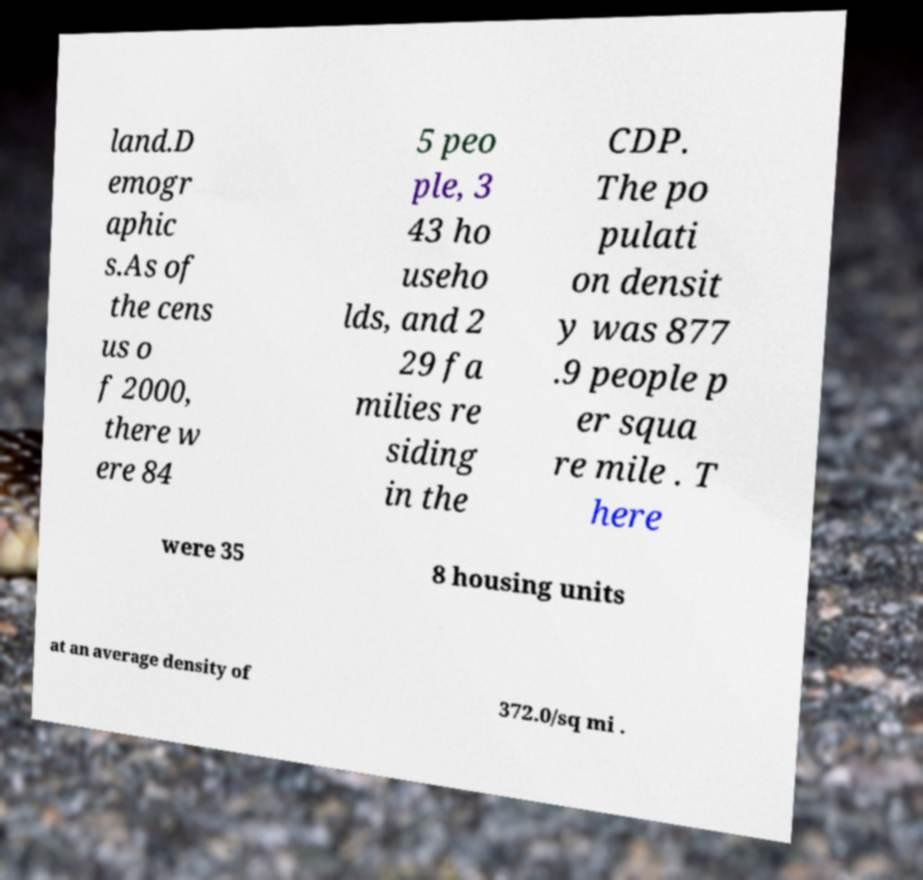Can you read and provide the text displayed in the image?This photo seems to have some interesting text. Can you extract and type it out for me? land.D emogr aphic s.As of the cens us o f 2000, there w ere 84 5 peo ple, 3 43 ho useho lds, and 2 29 fa milies re siding in the CDP. The po pulati on densit y was 877 .9 people p er squa re mile . T here were 35 8 housing units at an average density of 372.0/sq mi . 